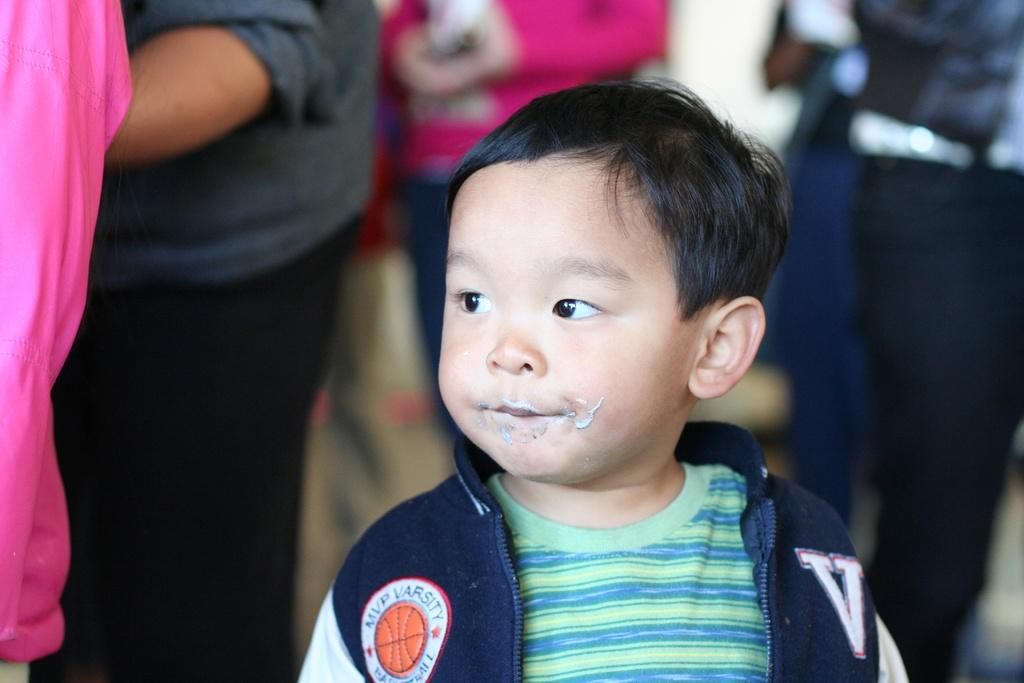<image>
Relay a brief, clear account of the picture shown. a boy that has mvp written on his jacket 